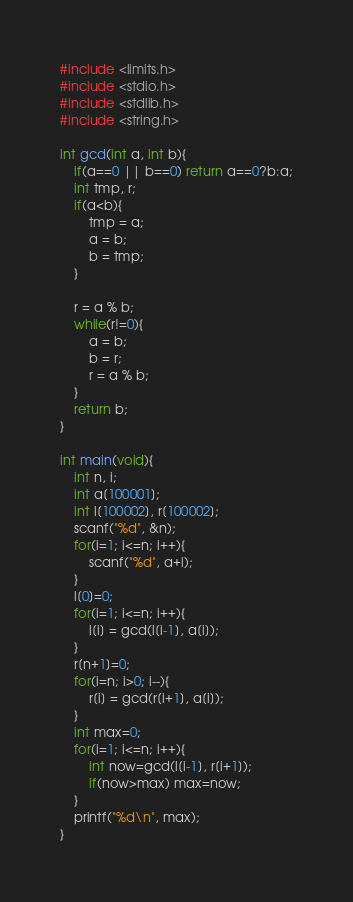<code> <loc_0><loc_0><loc_500><loc_500><_C_>#include <limits.h>
#include <stdio.h>
#include <stdlib.h>
#include <string.h>

int gcd(int a, int b){
	if(a==0 || b==0) return a==0?b:a;
	int tmp, r;
	if(a<b){
		tmp = a;
		a = b;
		b = tmp;
	}

	r = a % b;
	while(r!=0){
		a = b;
		b = r;
		r = a % b;
	}
	return b;
}

int main(void){
	int n, i;
	int a[100001];
	int l[100002], r[100002];
	scanf("%d", &n);
	for(i=1; i<=n; i++){
		scanf("%d", a+i);
	}
	l[0]=0;
	for(i=1; i<=n; i++){
		l[i] = gcd(l[i-1], a[i]);
	}
	r[n+1]=0;
	for(i=n; i>0; i--){
		r[i] = gcd(r[i+1], a[i]);
	}
	int max=0;
	for(i=1; i<=n; i++){
		int now=gcd(l[i-1], r[i+1]);
		if(now>max) max=now;
	}
	printf("%d\n", max);
}
</code> 